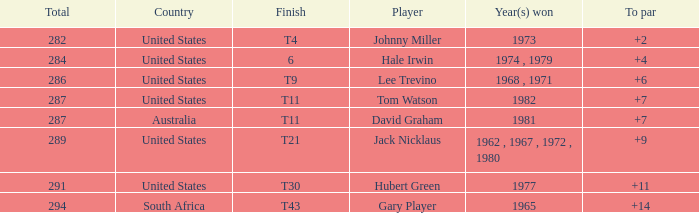WHAT IS THE TOTAL THAT HAS A WIN IN 1982? 287.0. 